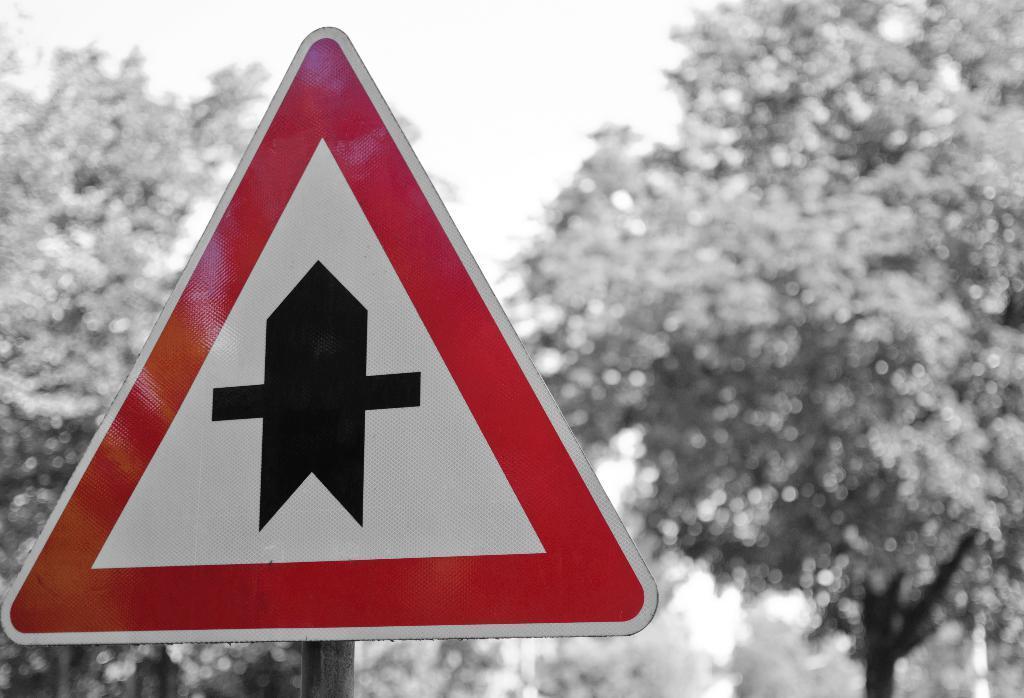How would you summarize this image in a sentence or two? In the background we can see the trees. In this picture we can see a sign board and a pole. 